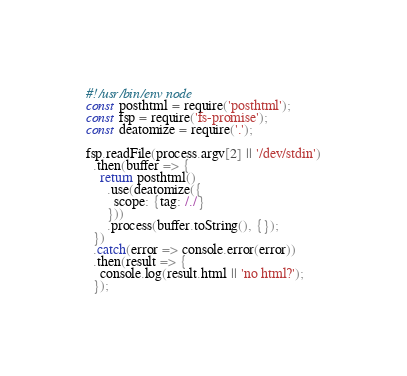<code> <loc_0><loc_0><loc_500><loc_500><_JavaScript_>#!/usr/bin/env node
const posthtml = require('posthtml');
const fsp = require('fs-promise');
const deatomize = require('.');

fsp.readFile(process.argv[2] || '/dev/stdin')
  .then(buffer => {
    return posthtml()
      .use(deatomize({
        scope: {tag: /./}
      }))
      .process(buffer.toString(), {});
  })
  .catch(error => console.error(error))
  .then(result => {
    console.log(result.html || 'no html?');
  });
</code> 